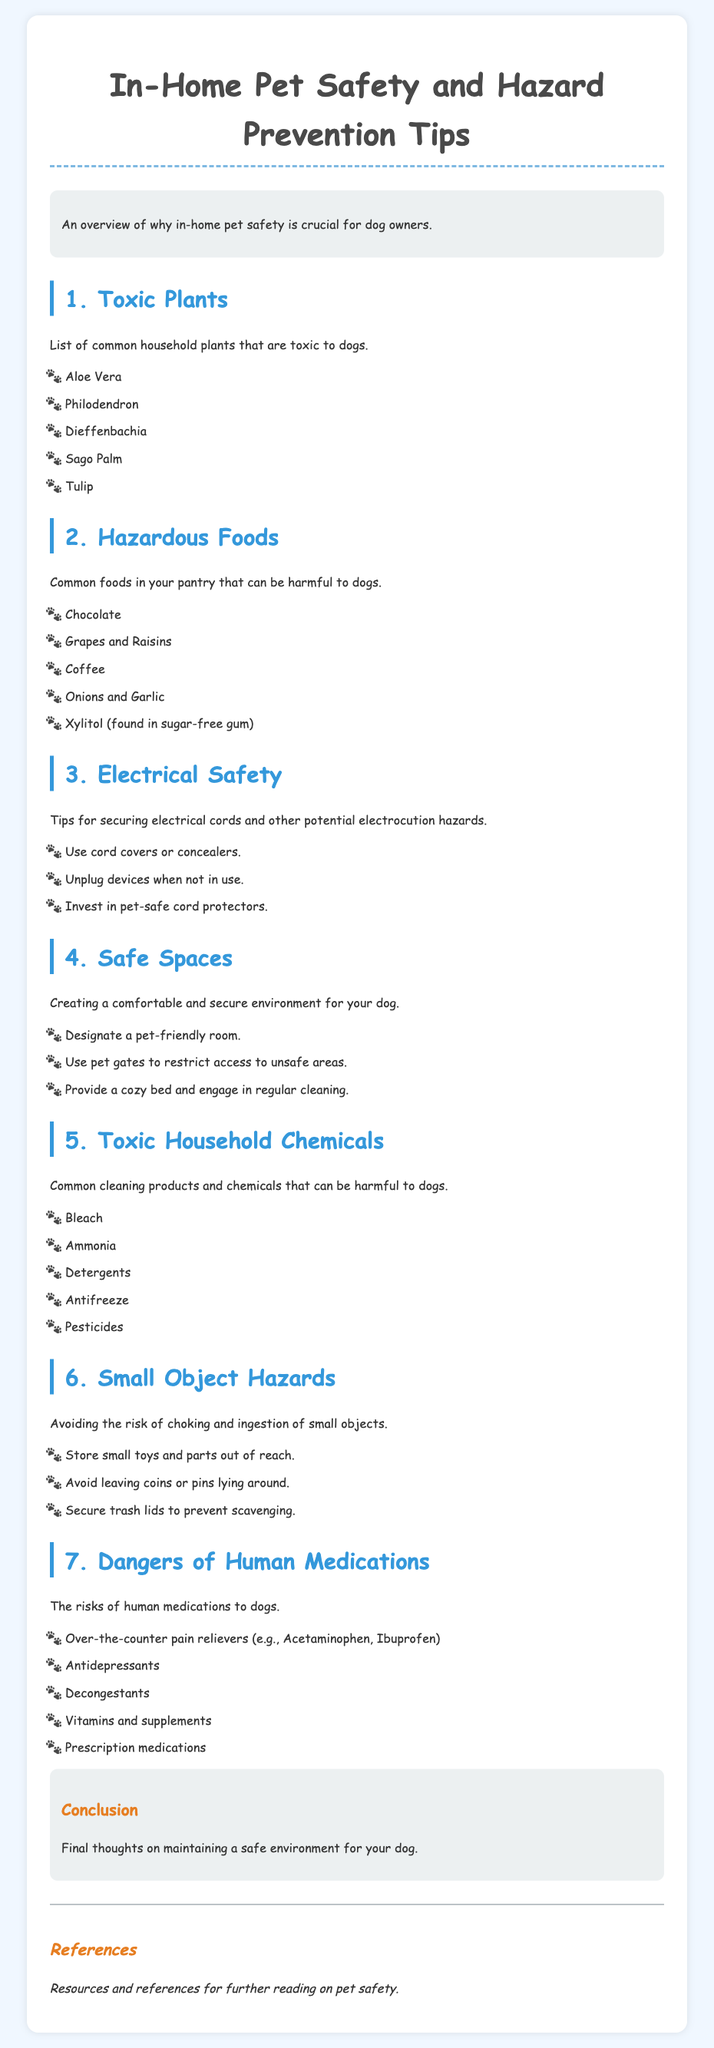What are common toxic plants for dogs? The document lists common household plants that are toxic to dogs, including Aloe Vera and Philodendron.
Answer: Aloe Vera, Philodendron What hazardous food is mentioned that is harmful to dogs? The document outlines common foods in pantries that can be harmful to dogs, including Chocolate and Grapes.
Answer: Chocolate, Grapes What is suggested for securing electrical cords? The document recommends several tips for securing electrical cords to prevent electrocution hazards.
Answer: Use cord covers or concealers How many tips are provided for creating safe spaces? The document provides three tips for creating a comfortable and secure environment for dogs.
Answer: Three What type of household chemicals should be avoided? The document lists common cleaning products and chemicals that can be harmful to dogs, such as Bleach and Ammonia.
Answer: Bleach, Ammonia What are small object hazards mentioned in the document? The document refers to the risks of choking and ingestion of small objects, stressing the importance of storing small toys and parts out of reach.
Answer: Store small toys and parts out of reach Which human medication is noted as dangerous for dogs? The document highlights various human medications that present risks to dogs, including Over-the-counter pain relievers like Acetaminophen.
Answer: Over-the-counter pain relievers What is the main purpose of the document? The document provides an overview of in-home pet safety and hazard prevention tips for dog owners.
Answer: Overview of in-home pet safety 